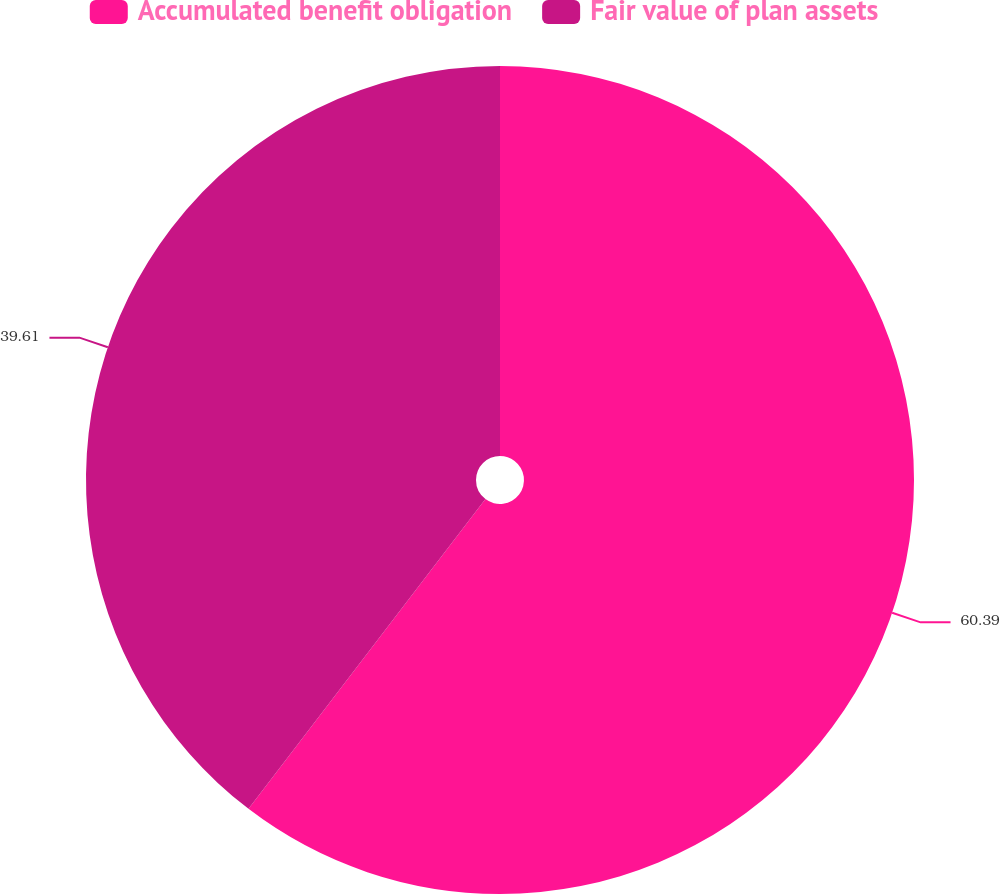<chart> <loc_0><loc_0><loc_500><loc_500><pie_chart><fcel>Accumulated benefit obligation<fcel>Fair value of plan assets<nl><fcel>60.39%<fcel>39.61%<nl></chart> 